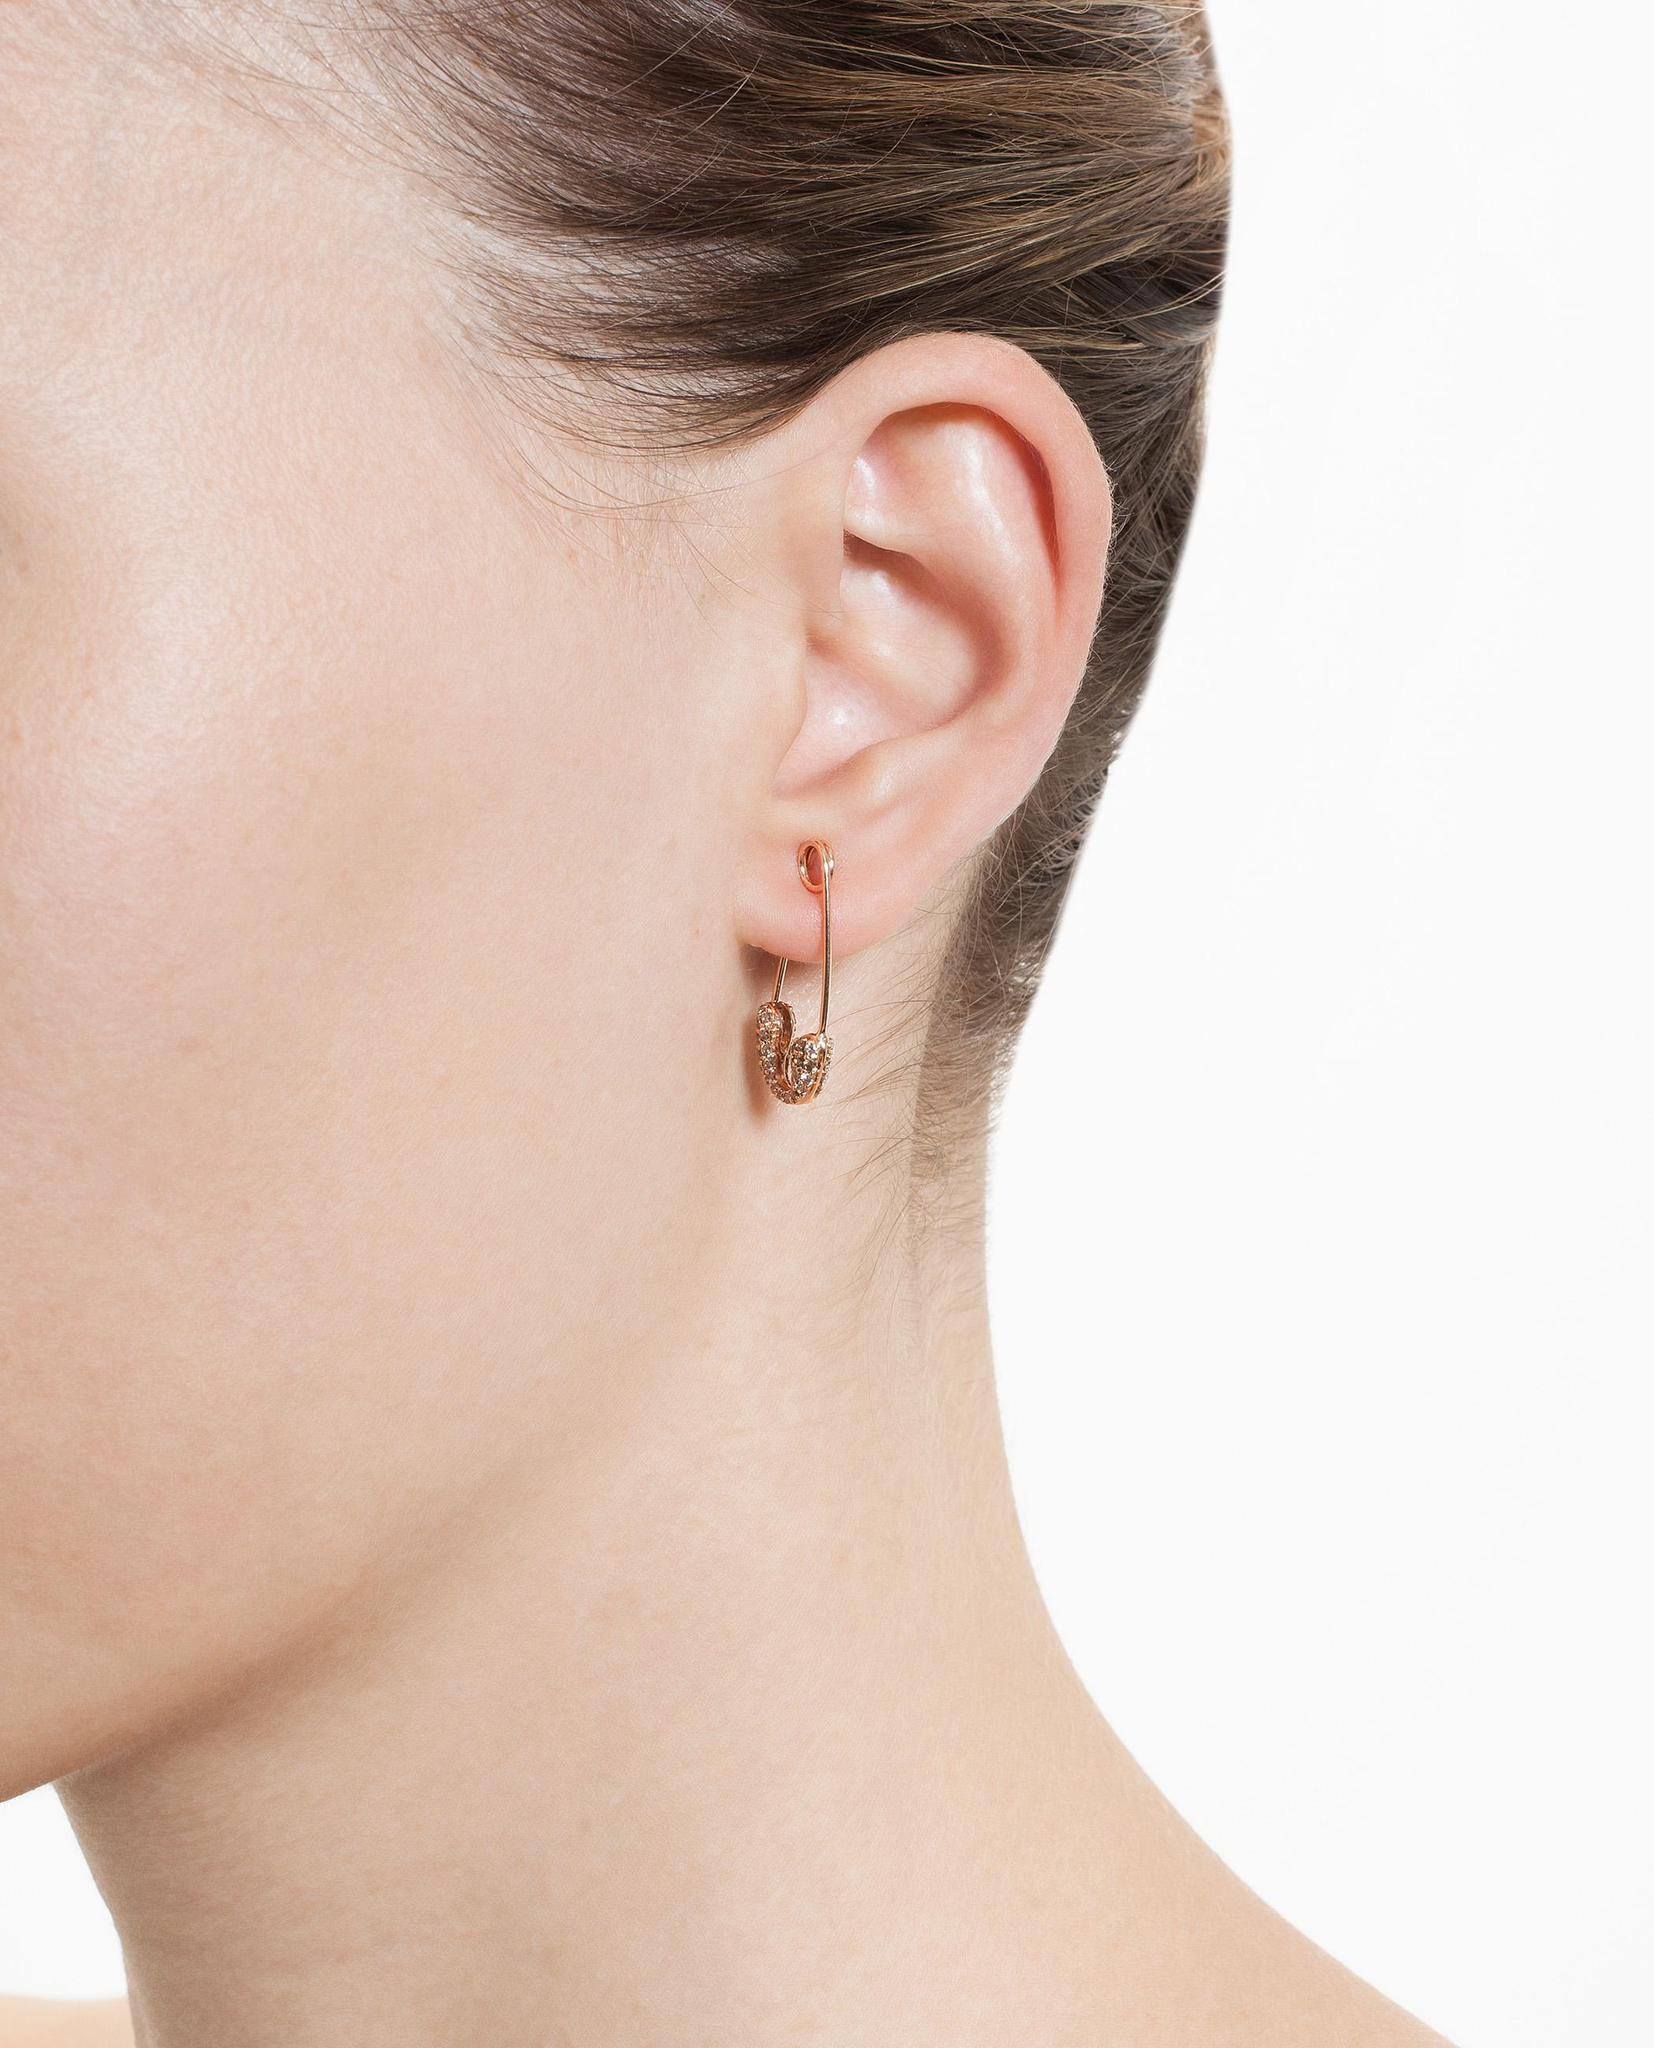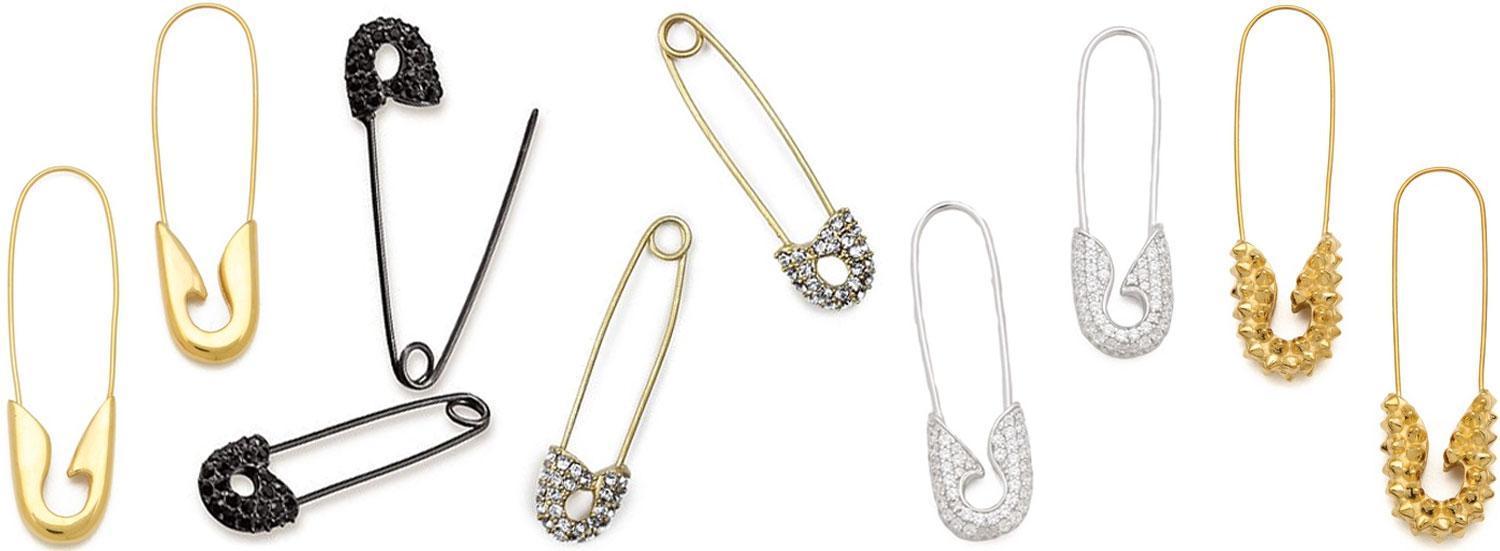The first image is the image on the left, the second image is the image on the right. For the images displayed, is the sentence "There is a woman wearing a safety pin earring in each image." factually correct? Answer yes or no. No. The first image is the image on the left, the second image is the image on the right. Considering the images on both sides, is "In each image, a woman with blonde hair is shown from the side with a small safety pin, clasp end pointed down, being used as a earring." valid? Answer yes or no. No. 